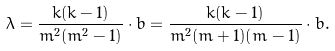<formula> <loc_0><loc_0><loc_500><loc_500>\lambda = \frac { k ( k - 1 ) } { m ^ { 2 } ( m ^ { 2 } - 1 ) } \cdot b = \frac { k ( k - 1 ) } { m ^ { 2 } ( m + 1 ) ( m - 1 ) } \cdot b .</formula> 